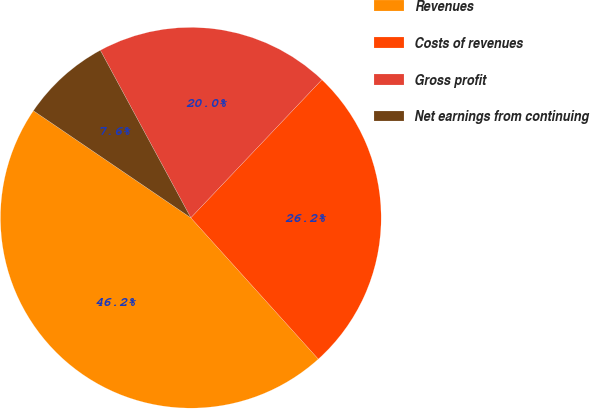Convert chart to OTSL. <chart><loc_0><loc_0><loc_500><loc_500><pie_chart><fcel>Revenues<fcel>Costs of revenues<fcel>Gross profit<fcel>Net earnings from continuing<nl><fcel>46.19%<fcel>26.23%<fcel>19.97%<fcel>7.61%<nl></chart> 